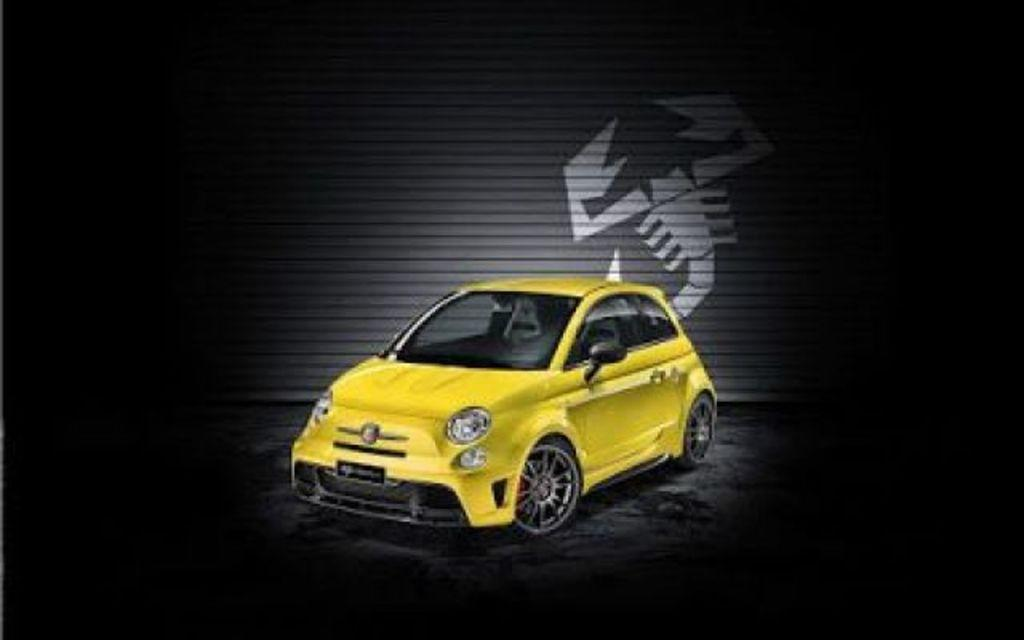What is the main subject of the image? The main subject of the image is a car. Can you describe anything else visible in the image? There is a shutter with a mark on it behind the car. What type of bread can be seen on the coast in the image? There is no bread or coast present in the image; it features a car and a shutter with a mark on it. 